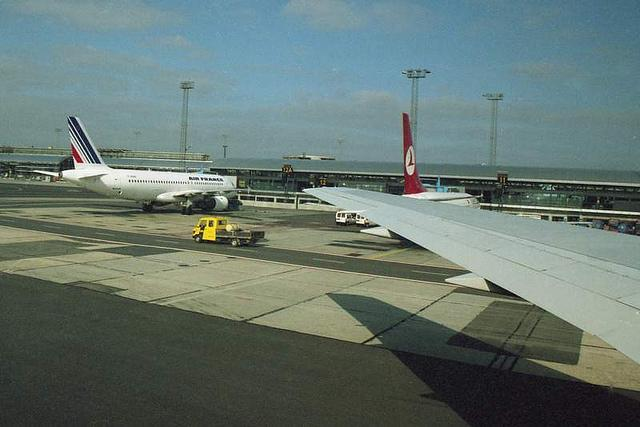What fuel does the plane require?

Choices:
A) coal
B) jetfuel
C) diesel
D) electricity jetfuel 